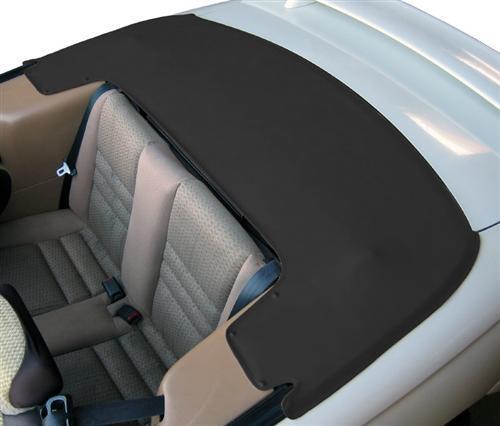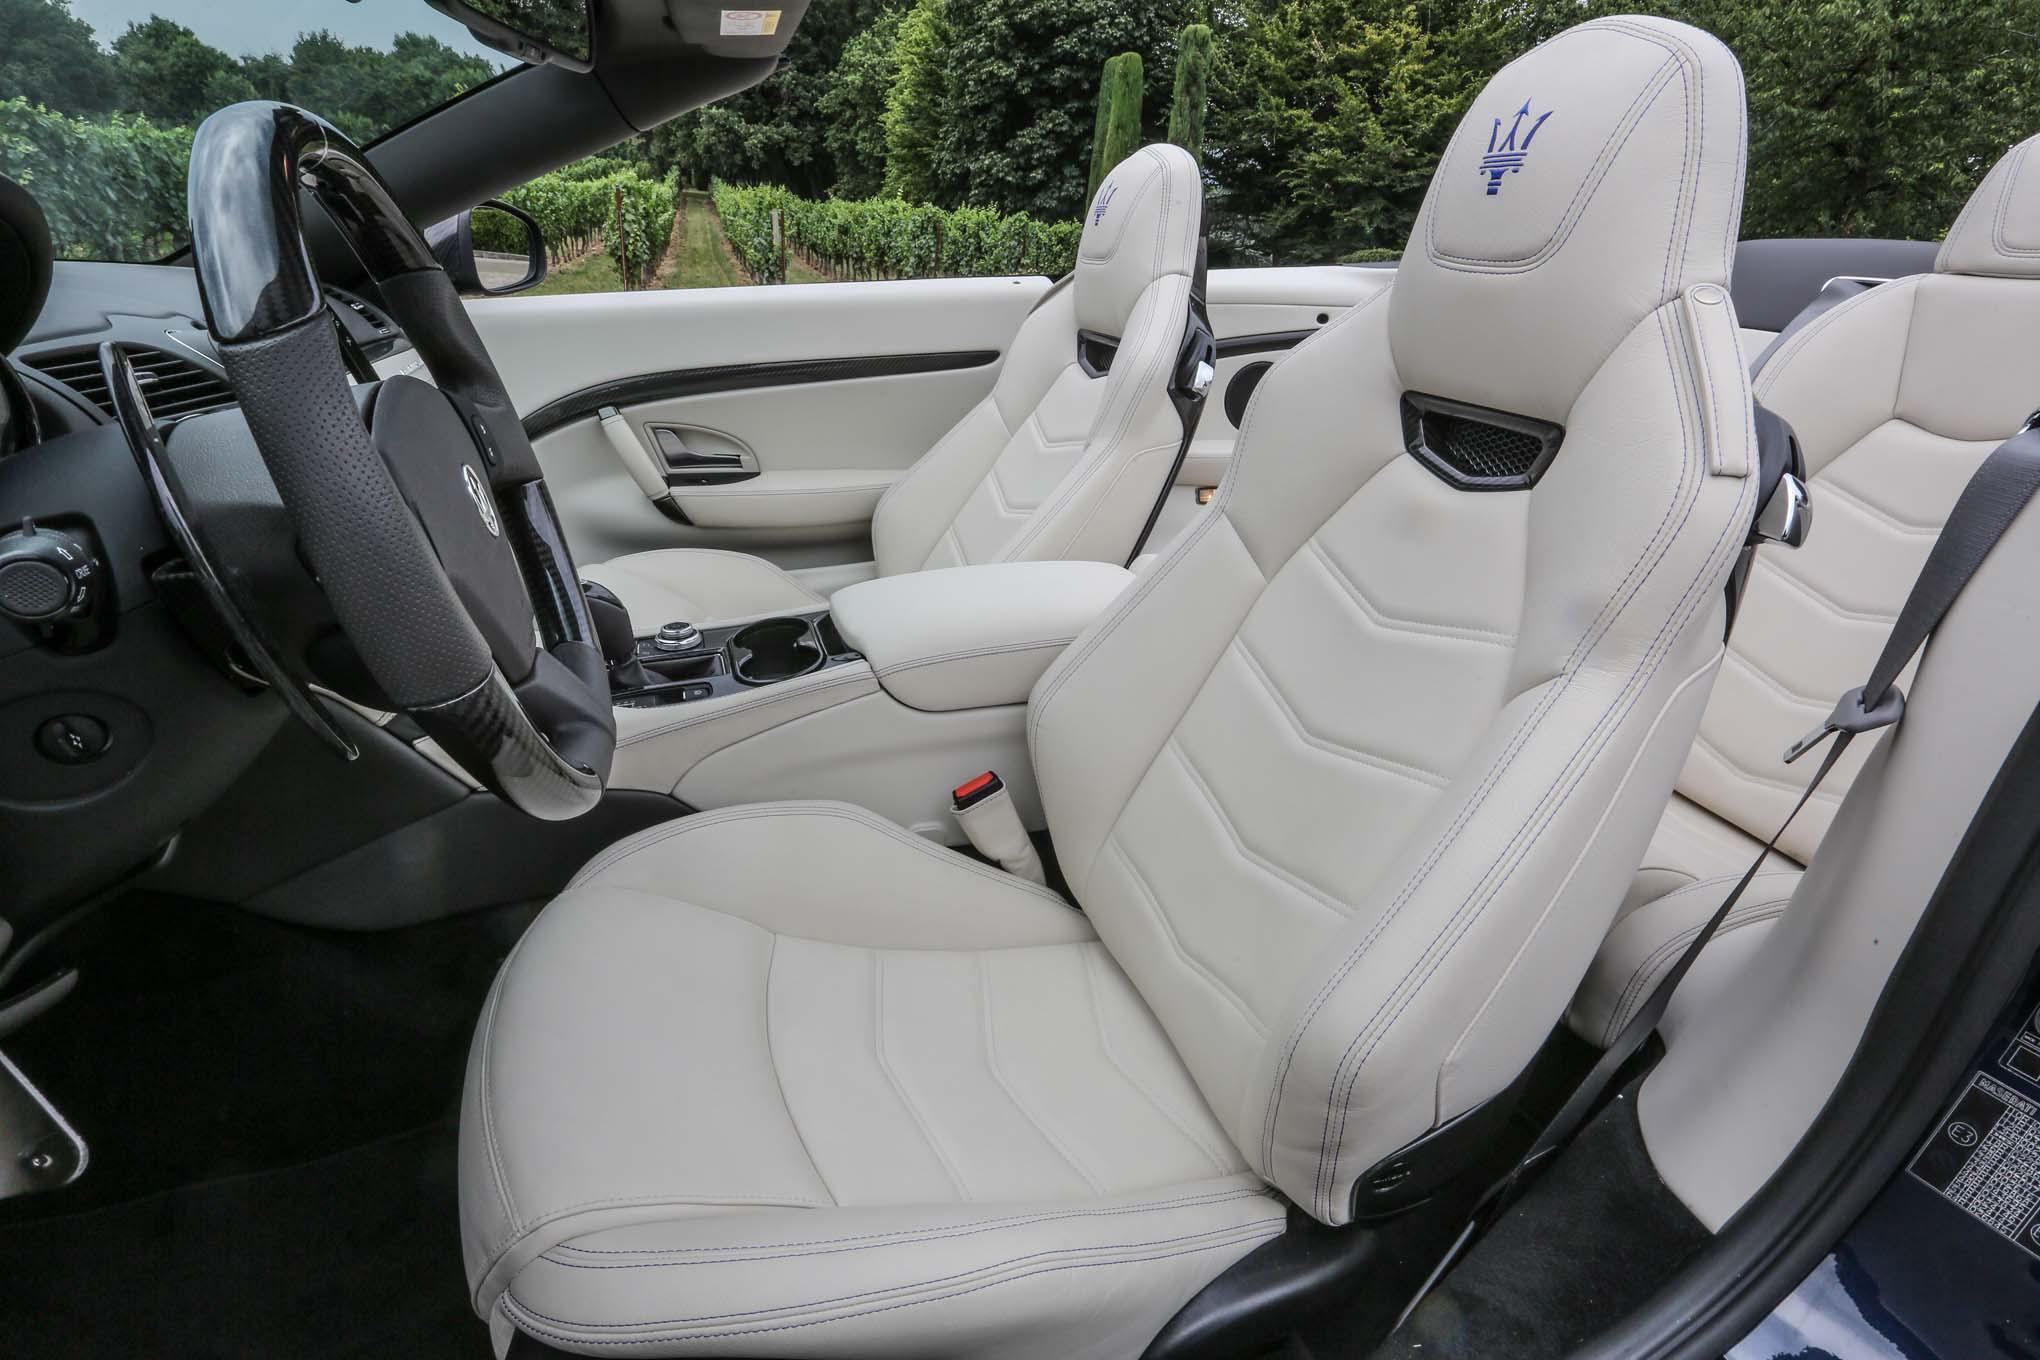The first image is the image on the left, the second image is the image on the right. For the images displayed, is the sentence "The black top of the car is rolled down in one of the images." factually correct? Answer yes or no. Yes. The first image is the image on the left, the second image is the image on the right. Given the left and right images, does the statement "One image shows white upholstered front seats and a darker steering wheel in a convertible car's interior, and the other image shows the folded soft top at the rear of the vehicle." hold true? Answer yes or no. Yes. 